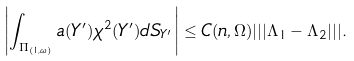Convert formula to latex. <formula><loc_0><loc_0><loc_500><loc_500>\left | \int _ { \Pi _ { ( 1 , \omega ) } } a ( Y ^ { \prime } ) \chi ^ { 2 } ( Y ^ { \prime } ) d S _ { Y ^ { \prime } } \right | \leq C ( n , \Omega ) | | | \Lambda _ { 1 } - \Lambda _ { 2 } | | | .</formula> 